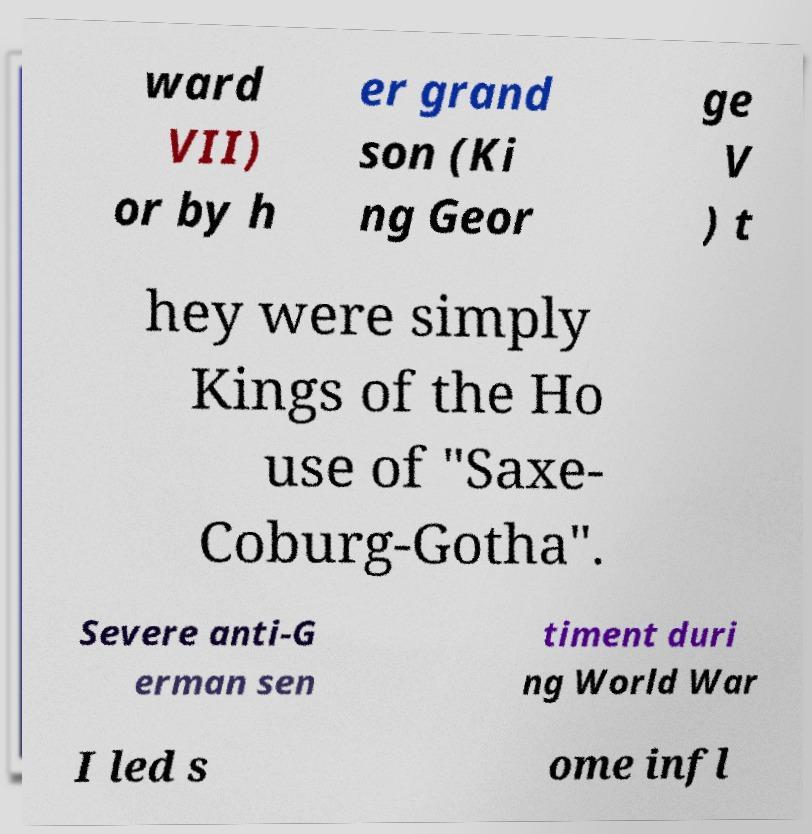Could you assist in decoding the text presented in this image and type it out clearly? ward VII) or by h er grand son (Ki ng Geor ge V ) t hey were simply Kings of the Ho use of "Saxe- Coburg-Gotha". Severe anti-G erman sen timent duri ng World War I led s ome infl 